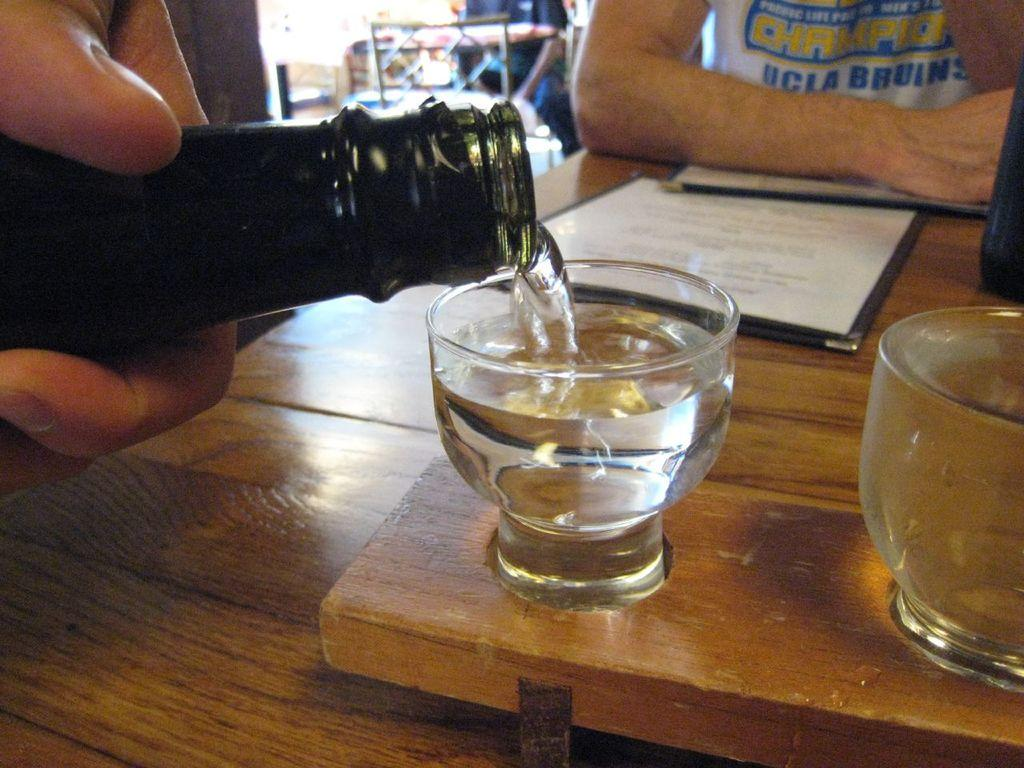<image>
Share a concise interpretation of the image provided. A guy at a bar wearing a UCLA BRUINS shirt. 